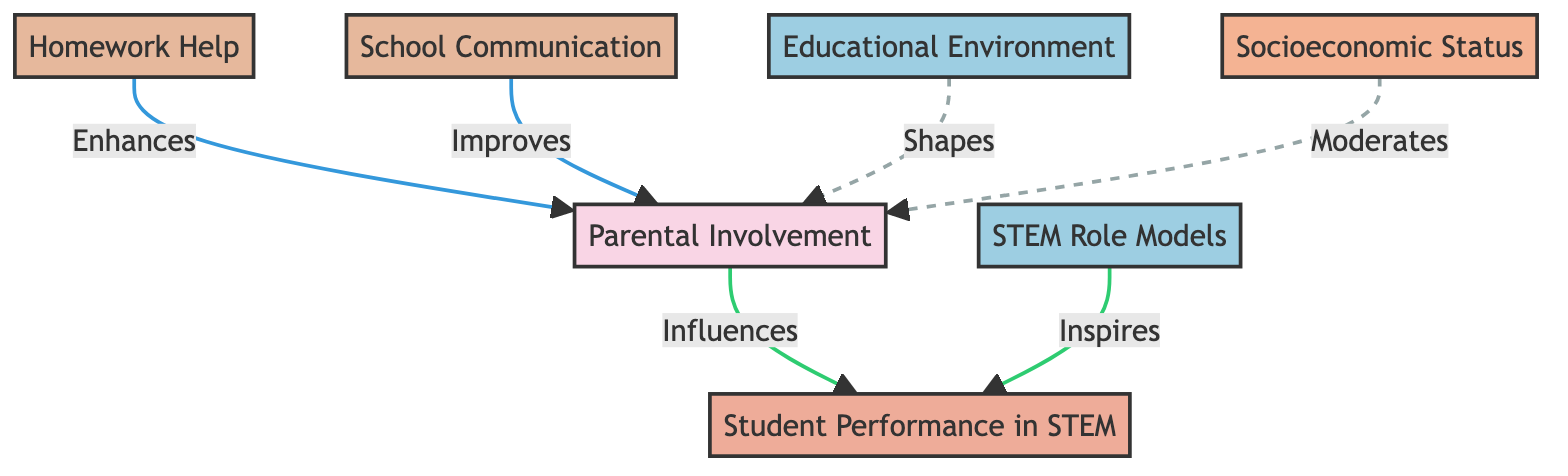What is the main factor influencing student performance in STEM? According to the diagram, the main factor influencing student performance in STEM is "Parental Involvement," which directly points to "Student Performance in STEM."
Answer: Parental Involvement How many actions are listed in the diagram? The diagram lists two actions: "Homework Help" and "School Communication." Therefore, by counting these nodes, we find there are two actions.
Answer: 2 Which component inspires student performance in STEM? The diagram shows that "STEM Role Models" inspire "Student Performance in STEM," signifying that role models have an encouraging effect on students’ performance in STEM subjects.
Answer: STEM Role Models What moderates the relationship between parental involvement and student performance? The diagram indicates that "Socioeconomic Status" moderates the relationship between "Parental Involvement" and "Student Performance in STEM," meaning it can influence how parental involvement affects student outcomes.
Answer: Socioeconomic Status Which context shapes parental involvement? The diagram illustrates that "Educational Environment" shapes "Parental Involvement," indicating that various educational contexts can have an impact on the level of parental engagement.
Answer: Educational Environment How does homework help influence parental involvement? According to the diagram, "Homework Help" enhances "Parental Involvement," indicating that assistance with homework can lead to increased engagement from parents.
Answer: Enhances What is the type of relationship between school communication and parental involvement? The diagram specifies that "School Communication" improves "Parental Involvement," which indicates a positive relationship where better communication likely leads to greater parental engagement.
Answer: Improves Which nodes are connected by dashed lines? The connections between "Educational Environment" and "Parental Involvement" as well as "Socioeconomic Status" and "Parental Involvement" are represented with dashed lines, indicating a different type of relationship than the solid lines show.
Answer: Educational Environment, Socioeconomic Status How many contexts are identified in the diagram? The diagram identifies two contexts: "Educational Environment" and "STEM Role Models," leading to a total of two context nodes being present.
Answer: 2 